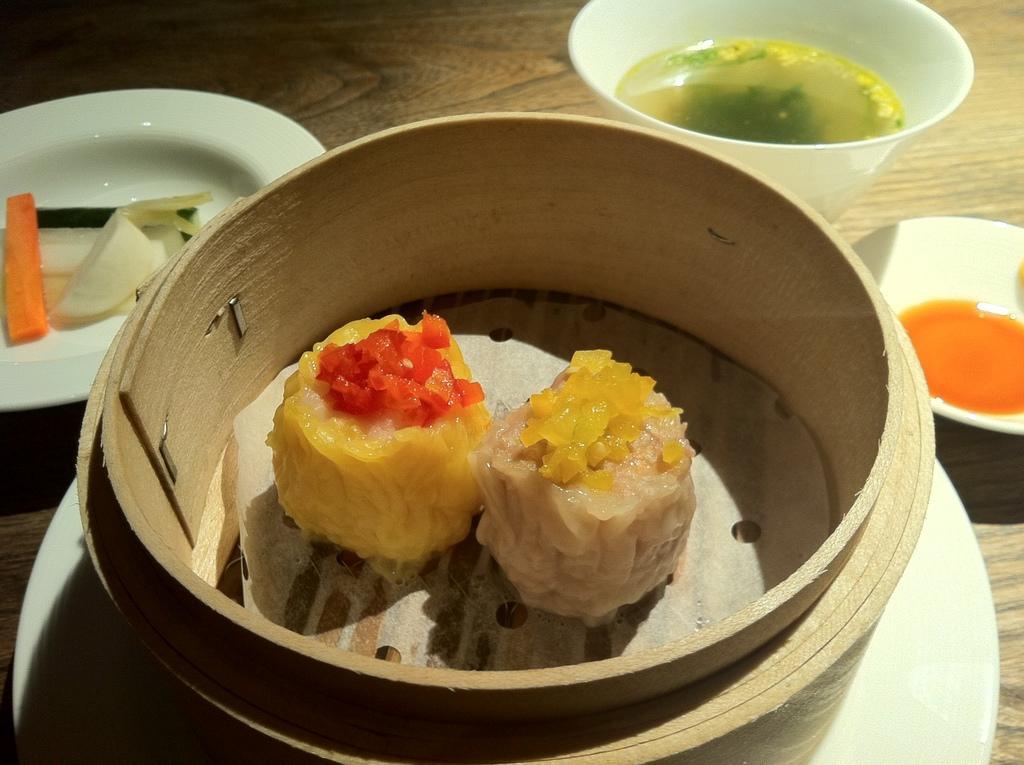Can you describe this image briefly? In this image we can see some food items, soups, fruits which are in the plates, bowls are on the wooden surface. 